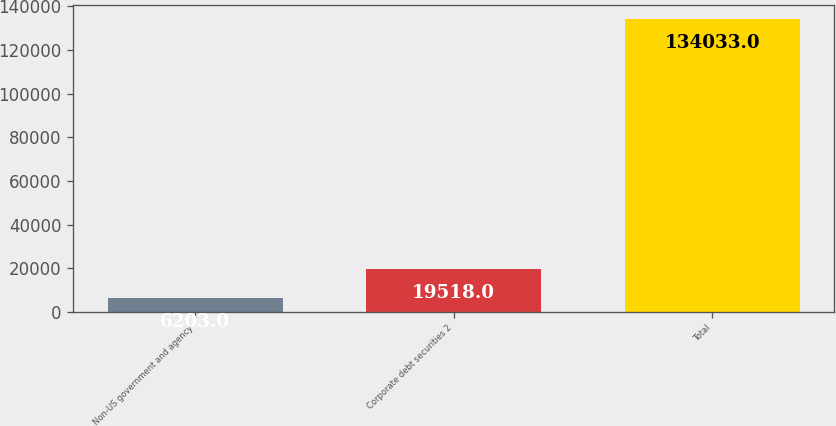Convert chart to OTSL. <chart><loc_0><loc_0><loc_500><loc_500><bar_chart><fcel>Non-US government and agency<fcel>Corporate debt securities 2<fcel>Total<nl><fcel>6203<fcel>19518<fcel>134033<nl></chart> 